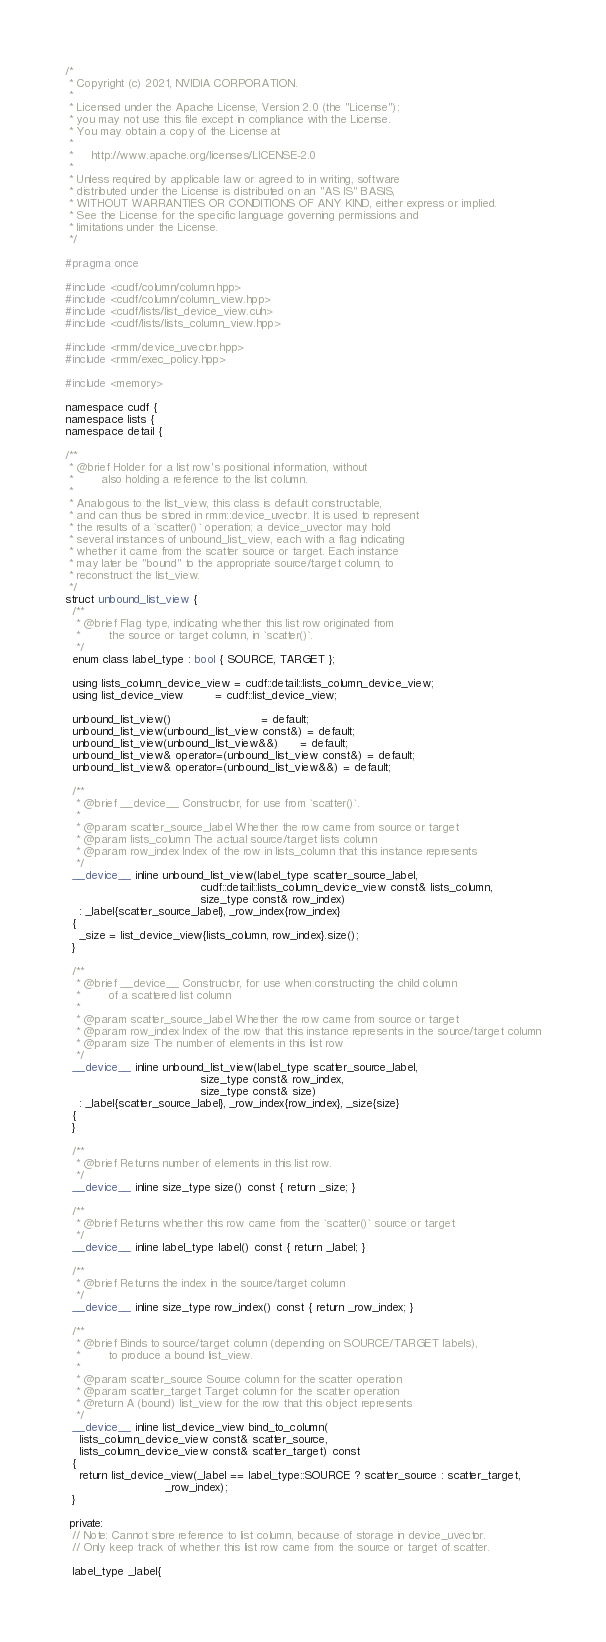Convert code to text. <code><loc_0><loc_0><loc_500><loc_500><_Cuda_>/*
 * Copyright (c) 2021, NVIDIA CORPORATION.
 *
 * Licensed under the Apache License, Version 2.0 (the "License");
 * you may not use this file except in compliance with the License.
 * You may obtain a copy of the License at
 *
 *     http://www.apache.org/licenses/LICENSE-2.0
 *
 * Unless required by applicable law or agreed to in writing, software
 * distributed under the License is distributed on an "AS IS" BASIS,
 * WITHOUT WARRANTIES OR CONDITIONS OF ANY KIND, either express or implied.
 * See the License for the specific language governing permissions and
 * limitations under the License.
 */

#pragma once

#include <cudf/column/column.hpp>
#include <cudf/column/column_view.hpp>
#include <cudf/lists/list_device_view.cuh>
#include <cudf/lists/lists_column_view.hpp>

#include <rmm/device_uvector.hpp>
#include <rmm/exec_policy.hpp>

#include <memory>

namespace cudf {
namespace lists {
namespace detail {

/**
 * @brief Holder for a list row's positional information, without
 *        also holding a reference to the list column.
 *
 * Analogous to the list_view, this class is default constructable,
 * and can thus be stored in rmm::device_uvector. It is used to represent
 * the results of a `scatter()` operation; a device_uvector may hold
 * several instances of unbound_list_view, each with a flag indicating
 * whether it came from the scatter source or target. Each instance
 * may later be "bound" to the appropriate source/target column, to
 * reconstruct the list_view.
 */
struct unbound_list_view {
  /**
   * @brief Flag type, indicating whether this list row originated from
   *        the source or target column, in `scatter()`.
   */
  enum class label_type : bool { SOURCE, TARGET };

  using lists_column_device_view = cudf::detail::lists_column_device_view;
  using list_device_view         = cudf::list_device_view;

  unbound_list_view()                         = default;
  unbound_list_view(unbound_list_view const&) = default;
  unbound_list_view(unbound_list_view&&)      = default;
  unbound_list_view& operator=(unbound_list_view const&) = default;
  unbound_list_view& operator=(unbound_list_view&&) = default;

  /**
   * @brief __device__ Constructor, for use from `scatter()`.
   *
   * @param scatter_source_label Whether the row came from source or target
   * @param lists_column The actual source/target lists column
   * @param row_index Index of the row in lists_column that this instance represents
   */
  __device__ inline unbound_list_view(label_type scatter_source_label,
                                      cudf::detail::lists_column_device_view const& lists_column,
                                      size_type const& row_index)
    : _label{scatter_source_label}, _row_index{row_index}
  {
    _size = list_device_view{lists_column, row_index}.size();
  }

  /**
   * @brief __device__ Constructor, for use when constructing the child column
   *        of a scattered list column
   *
   * @param scatter_source_label Whether the row came from source or target
   * @param row_index Index of the row that this instance represents in the source/target column
   * @param size The number of elements in this list row
   */
  __device__ inline unbound_list_view(label_type scatter_source_label,
                                      size_type const& row_index,
                                      size_type const& size)
    : _label{scatter_source_label}, _row_index{row_index}, _size{size}
  {
  }

  /**
   * @brief Returns number of elements in this list row.
   */
  __device__ inline size_type size() const { return _size; }

  /**
   * @brief Returns whether this row came from the `scatter()` source or target
   */
  __device__ inline label_type label() const { return _label; }

  /**
   * @brief Returns the index in the source/target column
   */
  __device__ inline size_type row_index() const { return _row_index; }

  /**
   * @brief Binds to source/target column (depending on SOURCE/TARGET labels),
   *        to produce a bound list_view.
   *
   * @param scatter_source Source column for the scatter operation
   * @param scatter_target Target column for the scatter operation
   * @return A (bound) list_view for the row that this object represents
   */
  __device__ inline list_device_view bind_to_column(
    lists_column_device_view const& scatter_source,
    lists_column_device_view const& scatter_target) const
  {
    return list_device_view(_label == label_type::SOURCE ? scatter_source : scatter_target,
                            _row_index);
  }

 private:
  // Note: Cannot store reference to list column, because of storage in device_uvector.
  // Only keep track of whether this list row came from the source or target of scatter.

  label_type _label{</code> 